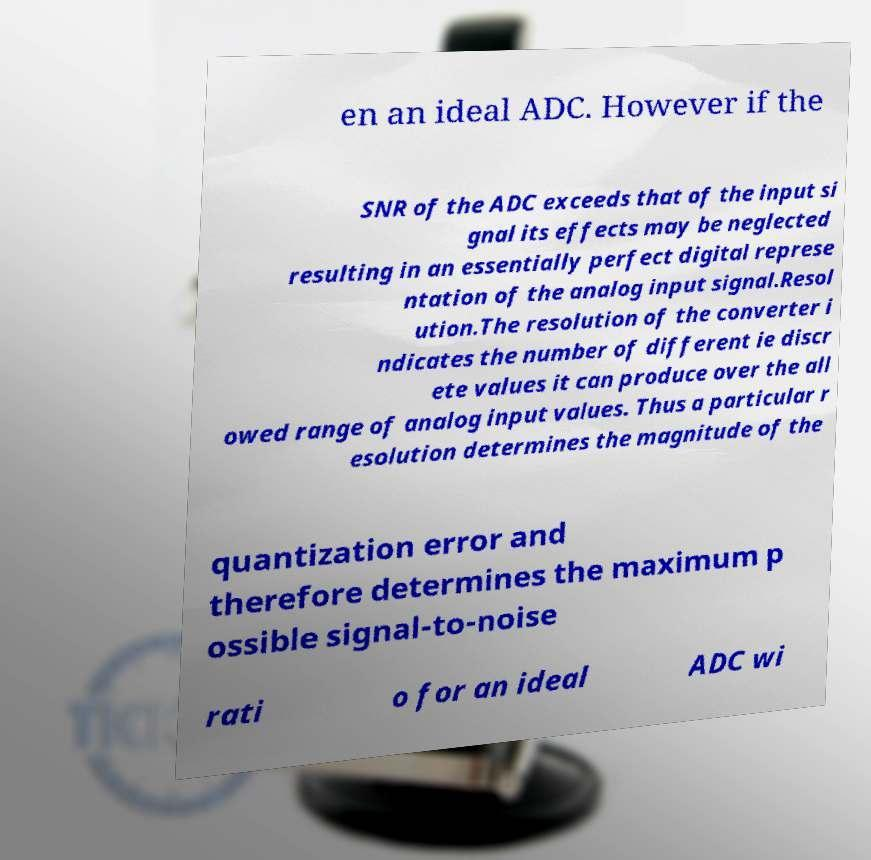Can you accurately transcribe the text from the provided image for me? en an ideal ADC. However if the SNR of the ADC exceeds that of the input si gnal its effects may be neglected resulting in an essentially perfect digital represe ntation of the analog input signal.Resol ution.The resolution of the converter i ndicates the number of different ie discr ete values it can produce over the all owed range of analog input values. Thus a particular r esolution determines the magnitude of the quantization error and therefore determines the maximum p ossible signal-to-noise rati o for an ideal ADC wi 